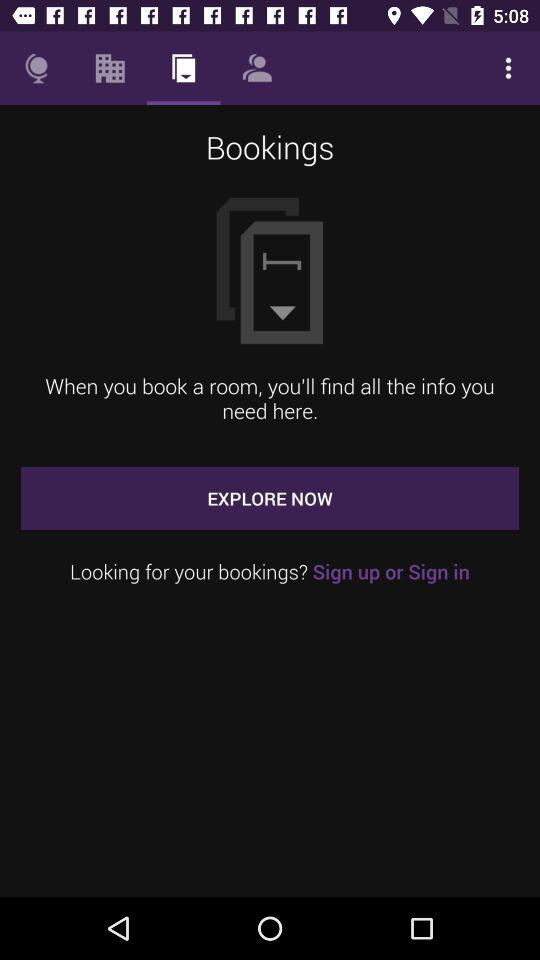Which tab is selected? The selected tab is "Bookings". 